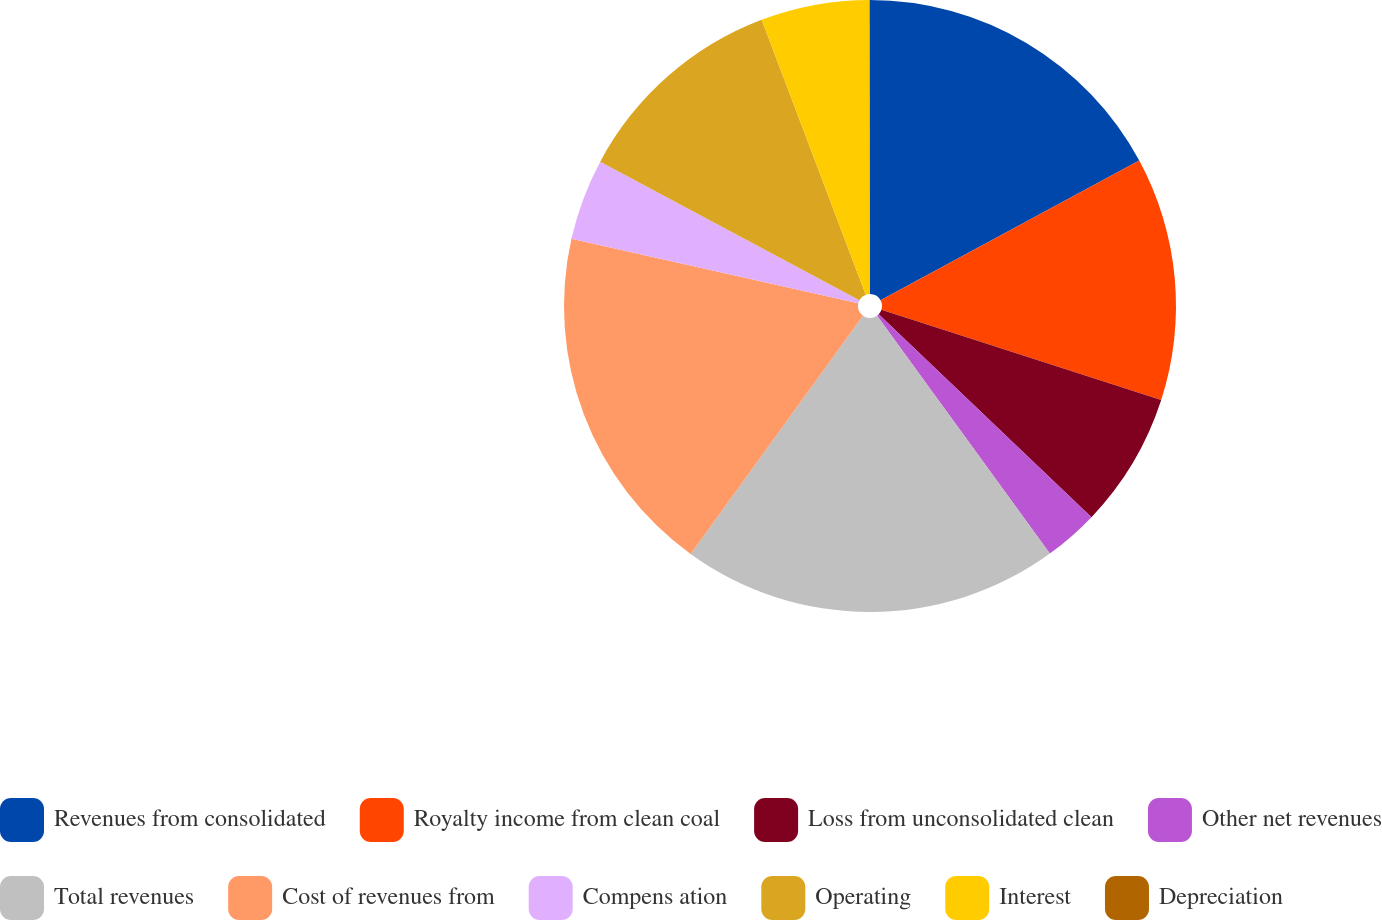Convert chart. <chart><loc_0><loc_0><loc_500><loc_500><pie_chart><fcel>Revenues from consolidated<fcel>Royalty income from clean coal<fcel>Loss from unconsolidated clean<fcel>Other net revenues<fcel>Total revenues<fcel>Cost of revenues from<fcel>Compens ation<fcel>Operating<fcel>Interest<fcel>Depreciation<nl><fcel>17.12%<fcel>12.85%<fcel>7.15%<fcel>2.88%<fcel>19.97%<fcel>18.55%<fcel>4.3%<fcel>11.42%<fcel>5.73%<fcel>0.03%<nl></chart> 